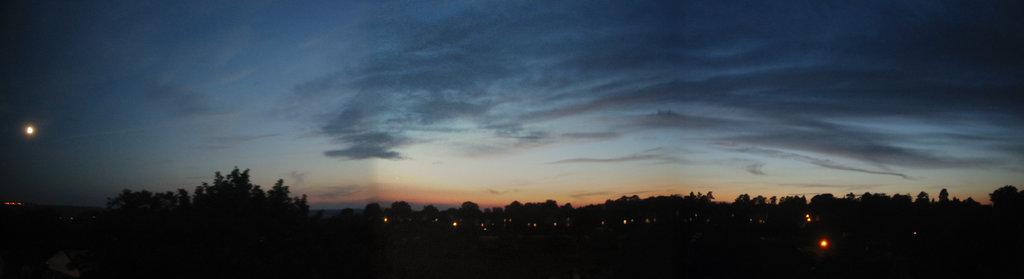What is located in the center of the image? There are trees and lights in the center of the image. What can be seen in the sky at the top of the image? Clouds are visible in the sky at the top of the image. Where is the moon located in the image? The moon is present on the left side of the image. What line can be seen connecting the trees and the moon in the image? There is no line connecting the trees and the moon in the image. What is the name of the person who took the picture of the image? The provided facts do not include any information about the person who took the picture, so we cannot determine their name. 